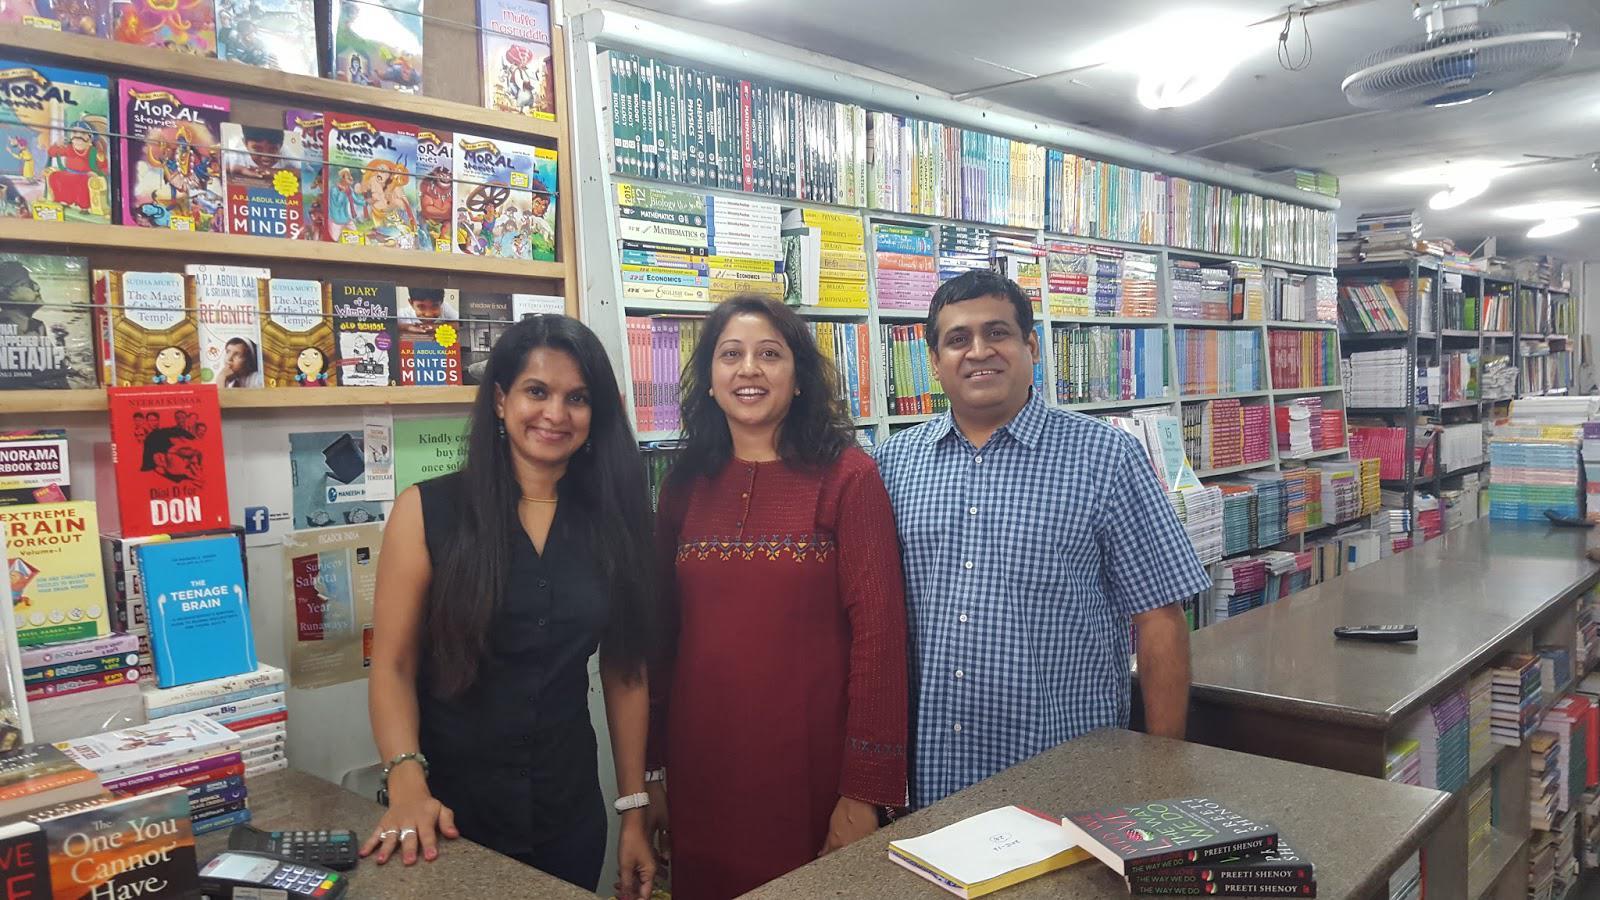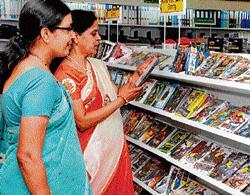The first image is the image on the left, the second image is the image on the right. Evaluate the accuracy of this statement regarding the images: "Both images are have a few bookshelves close up, and no people.". Is it true? Answer yes or no. No. The first image is the image on the left, the second image is the image on the right. Considering the images on both sides, is "One image shows book-type items displayed vertically on shelves viewed head-on, and neither image shows people standing in a store." valid? Answer yes or no. No. 